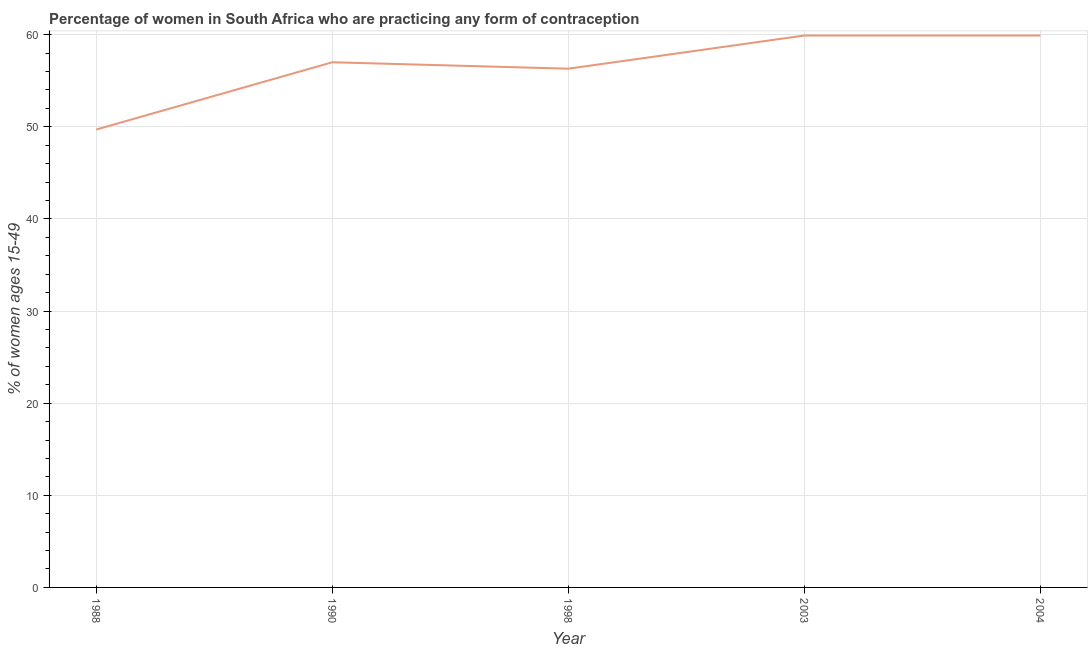What is the contraceptive prevalence in 1990?
Your response must be concise. 57. Across all years, what is the maximum contraceptive prevalence?
Provide a succinct answer. 59.9. Across all years, what is the minimum contraceptive prevalence?
Your response must be concise. 49.7. What is the sum of the contraceptive prevalence?
Keep it short and to the point. 282.8. What is the difference between the contraceptive prevalence in 1988 and 1998?
Ensure brevity in your answer.  -6.6. What is the average contraceptive prevalence per year?
Your response must be concise. 56.56. In how many years, is the contraceptive prevalence greater than 38 %?
Make the answer very short. 5. What is the ratio of the contraceptive prevalence in 1998 to that in 2003?
Your response must be concise. 0.94. Is the contraceptive prevalence in 1990 less than that in 2004?
Offer a very short reply. Yes. What is the difference between the highest and the second highest contraceptive prevalence?
Provide a short and direct response. 0. What is the difference between the highest and the lowest contraceptive prevalence?
Offer a very short reply. 10.2. How many years are there in the graph?
Ensure brevity in your answer.  5. Are the values on the major ticks of Y-axis written in scientific E-notation?
Provide a succinct answer. No. Does the graph contain grids?
Offer a very short reply. Yes. What is the title of the graph?
Offer a very short reply. Percentage of women in South Africa who are practicing any form of contraception. What is the label or title of the Y-axis?
Your answer should be very brief. % of women ages 15-49. What is the % of women ages 15-49 of 1988?
Provide a short and direct response. 49.7. What is the % of women ages 15-49 in 1998?
Offer a very short reply. 56.3. What is the % of women ages 15-49 of 2003?
Make the answer very short. 59.9. What is the % of women ages 15-49 of 2004?
Make the answer very short. 59.9. What is the difference between the % of women ages 15-49 in 1988 and 1990?
Your response must be concise. -7.3. What is the difference between the % of women ages 15-49 in 1988 and 1998?
Offer a terse response. -6.6. What is the difference between the % of women ages 15-49 in 1988 and 2003?
Your answer should be compact. -10.2. What is the difference between the % of women ages 15-49 in 1990 and 1998?
Your response must be concise. 0.7. What is the difference between the % of women ages 15-49 in 1990 and 2003?
Your response must be concise. -2.9. What is the difference between the % of women ages 15-49 in 1998 and 2003?
Your response must be concise. -3.6. What is the difference between the % of women ages 15-49 in 1998 and 2004?
Ensure brevity in your answer.  -3.6. What is the difference between the % of women ages 15-49 in 2003 and 2004?
Offer a very short reply. 0. What is the ratio of the % of women ages 15-49 in 1988 to that in 1990?
Offer a very short reply. 0.87. What is the ratio of the % of women ages 15-49 in 1988 to that in 1998?
Keep it short and to the point. 0.88. What is the ratio of the % of women ages 15-49 in 1988 to that in 2003?
Provide a succinct answer. 0.83. What is the ratio of the % of women ages 15-49 in 1988 to that in 2004?
Your response must be concise. 0.83. What is the ratio of the % of women ages 15-49 in 1990 to that in 1998?
Offer a very short reply. 1.01. What is the ratio of the % of women ages 15-49 in 1990 to that in 2003?
Ensure brevity in your answer.  0.95. What is the ratio of the % of women ages 15-49 in 1998 to that in 2003?
Offer a terse response. 0.94. What is the ratio of the % of women ages 15-49 in 2003 to that in 2004?
Give a very brief answer. 1. 